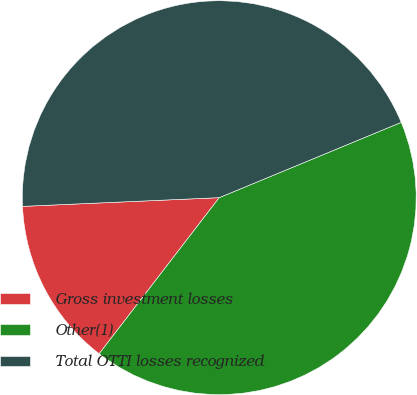<chart> <loc_0><loc_0><loc_500><loc_500><pie_chart><fcel>Gross investment losses<fcel>Other(1)<fcel>Total OTTI losses recognized<nl><fcel>13.86%<fcel>41.68%<fcel>44.46%<nl></chart> 